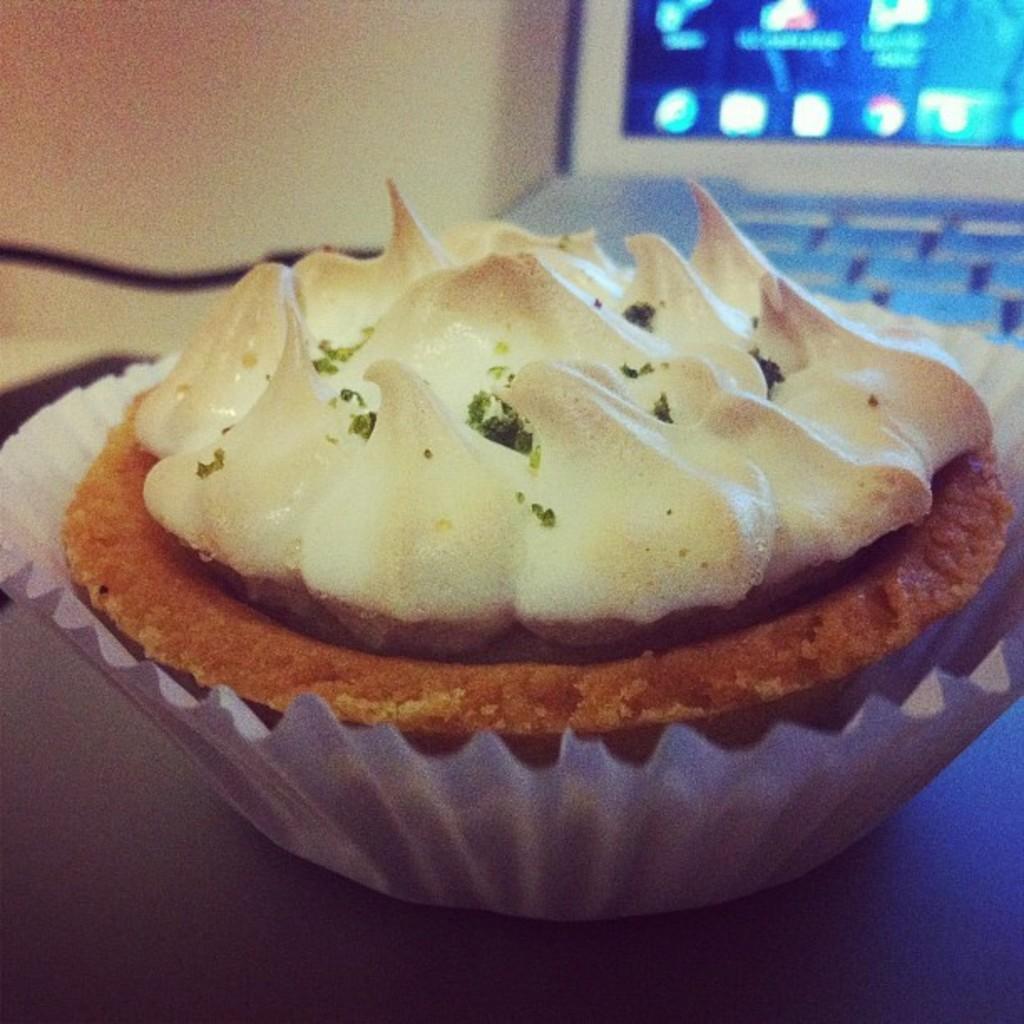How would you summarize this image in a sentence or two? In this image we can see a cupcake placed on the table. In the background, we can see a laptop. 